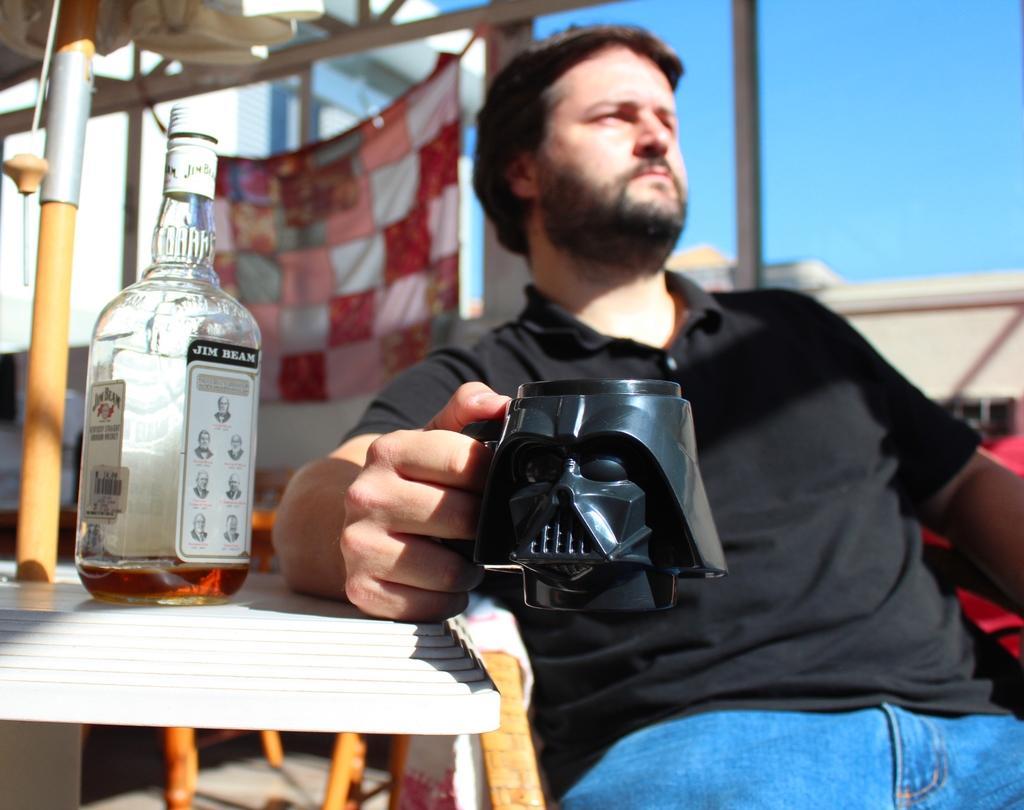In one or two sentences, can you explain what this image depicts? In the middle a man is sitting on the chair he is holding a cup he wear a black t shirt and trouser he is starting something. On the left there is a table on that table there is a bottle with some drink on that. In the background there is a sky,building and cloth. 